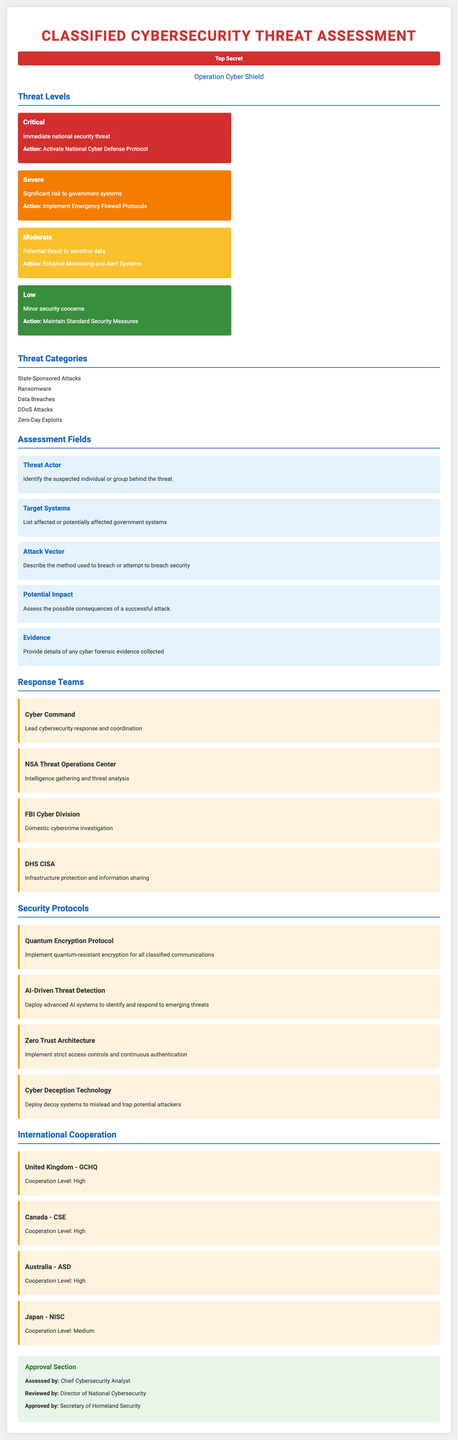what is the classification of the document? The classification is a designation indicating the sensitivity of the content, which is specified in the document.
Answer: Top Secret what is the name of the operation? The operation name is provided to identify the specific cybersecurity initiative addressed in the document.
Answer: Operation Cyber Shield how many threat levels are listed? The document enumerates different risk categories, which is indicated within the threat levels section.
Answer: Four what color represents a critical threat level? The color-coded system reflects varying levels of threat, and specific colors signify different categories within that system.
Answer: Red which team is responsible for intelligence gathering? The responsibility for intelligence relates to a specific response team outlined in the document.
Answer: NSA Threat Operations Center what is the recommended action for a severe threat? Each threat level is associated with a specific response approach, which is detailed for ease of execution.
Answer: Implement Emergency Firewall Protocols which country has a medium level of cooperation? The document lists countries with their respective cooperation levels, indicating their alliances in cybersecurity.
Answer: Japan how many security protocols are listed? The number of strategies provided for enhancing cybersecurity measures is explicitly noted in the document.
Answer: Four who approved the assessment? Approval by key officials is documented to signify the validation of the assessment and its conclusions.
Answer: Secretary of Homeland Security 